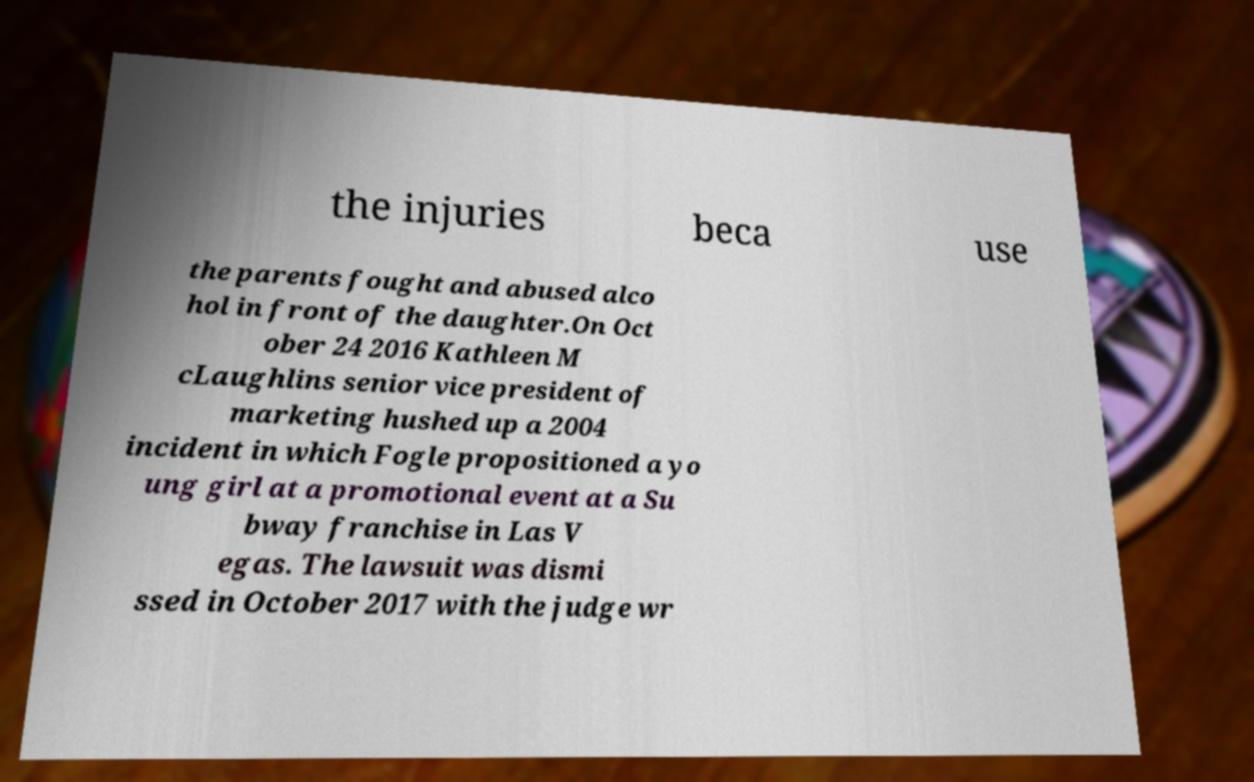Can you read and provide the text displayed in the image?This photo seems to have some interesting text. Can you extract and type it out for me? the injuries beca use the parents fought and abused alco hol in front of the daughter.On Oct ober 24 2016 Kathleen M cLaughlins senior vice president of marketing hushed up a 2004 incident in which Fogle propositioned a yo ung girl at a promotional event at a Su bway franchise in Las V egas. The lawsuit was dismi ssed in October 2017 with the judge wr 